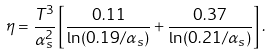<formula> <loc_0><loc_0><loc_500><loc_500>\eta = \frac { T ^ { 3 } } { \alpha _ { s } ^ { 2 } } \left [ \frac { 0 . 1 1 } { \ln ( 0 . 1 9 / \alpha _ { s } ) } + \frac { 0 . 3 7 } { \ln ( 0 . 2 1 / \alpha _ { s } ) } \right ] .</formula> 